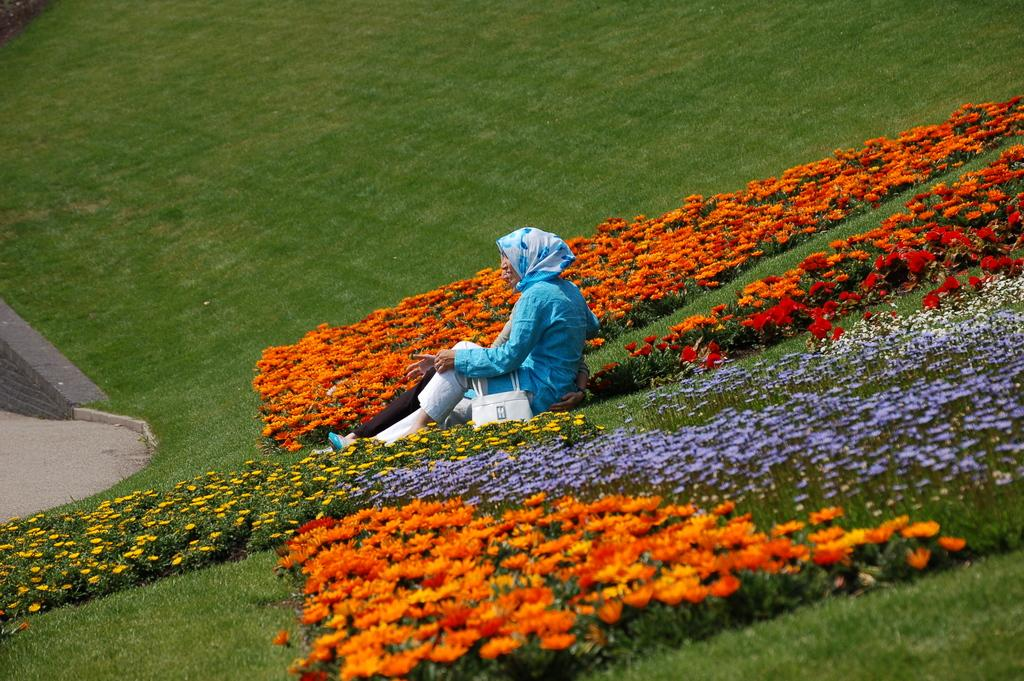What types of vegetation can be seen in the image? There are plants and flowers in the image. What is the person in the image doing? The person is sitting on the grass in the image. What can be seen on the left side of the image? There is a road on the left side of the image. What is the tendency of the list in the image? There is no list present in the image. How is the measure of the person sitting on the grass determined in the image? The image does not provide any information to determine the measure of the person sitting on the grass. 